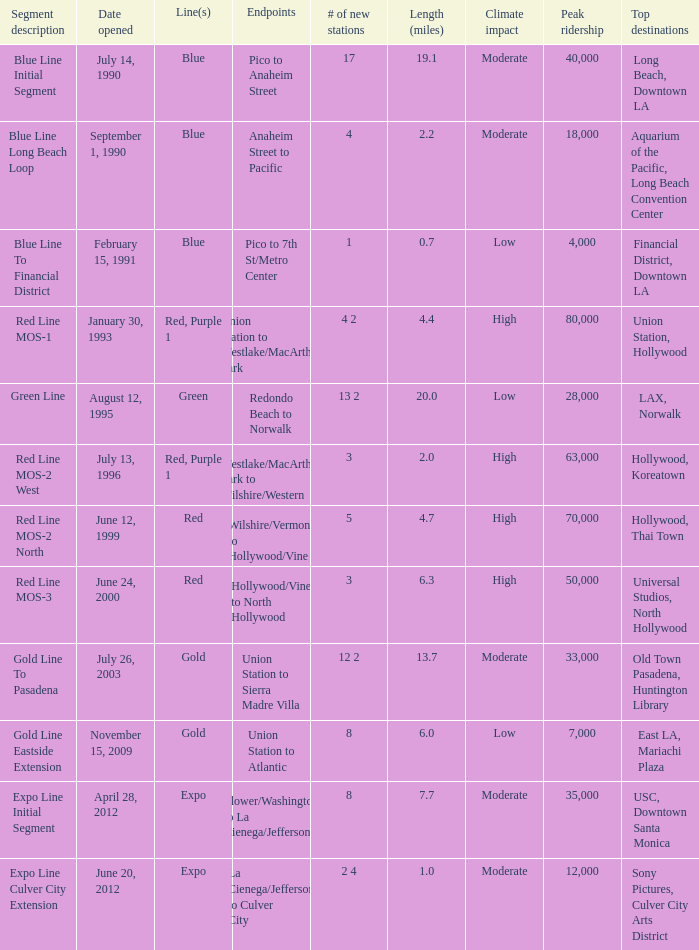What is the length  (miles) when pico to 7th st/metro center are the endpoints? 0.7. 